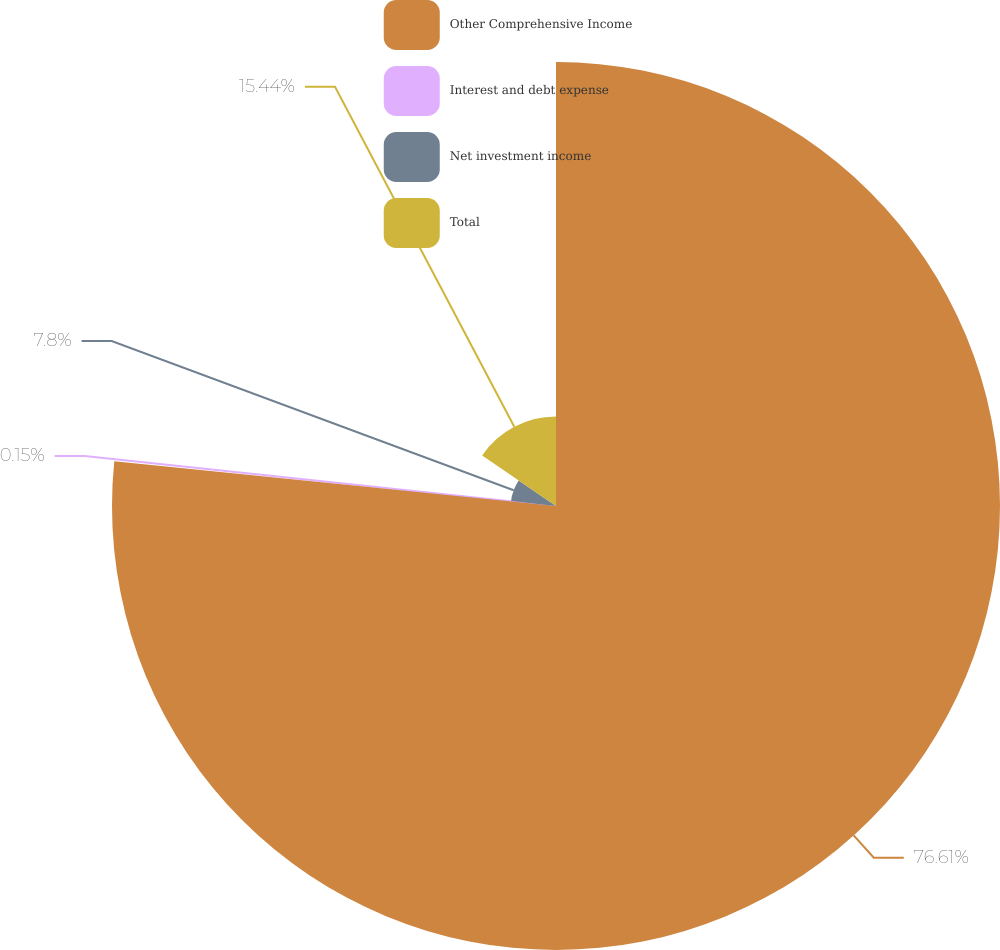Convert chart to OTSL. <chart><loc_0><loc_0><loc_500><loc_500><pie_chart><fcel>Other Comprehensive Income<fcel>Interest and debt expense<fcel>Net investment income<fcel>Total<nl><fcel>76.61%<fcel>0.15%<fcel>7.8%<fcel>15.44%<nl></chart> 